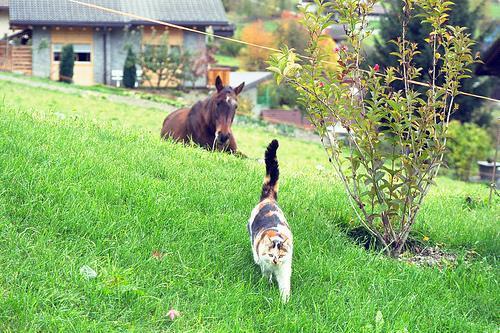How many animals are there?
Give a very brief answer. 2. 